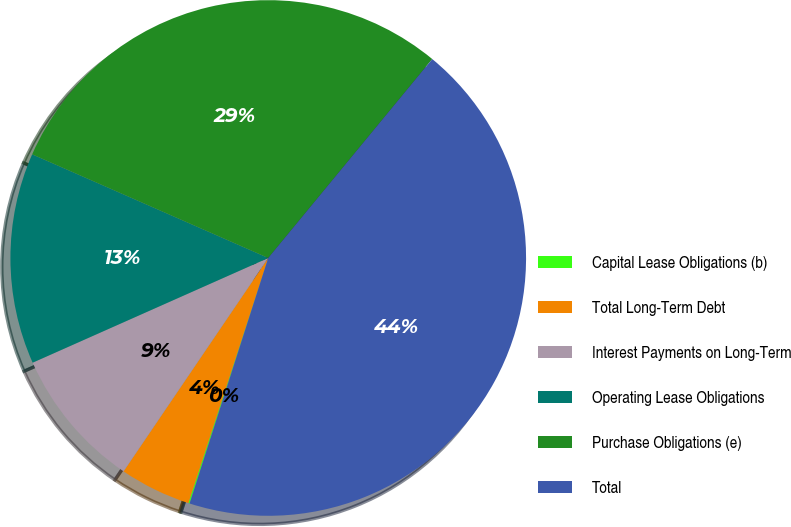Convert chart. <chart><loc_0><loc_0><loc_500><loc_500><pie_chart><fcel>Capital Lease Obligations (b)<fcel>Total Long-Term Debt<fcel>Interest Payments on Long-Term<fcel>Operating Lease Obligations<fcel>Purchase Obligations (e)<fcel>Total<nl><fcel>0.08%<fcel>4.47%<fcel>8.86%<fcel>13.24%<fcel>29.39%<fcel>43.96%<nl></chart> 